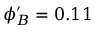Convert formula to latex. <formula><loc_0><loc_0><loc_500><loc_500>\phi _ { B } ^ { \prime } = 0 . 1 1</formula> 